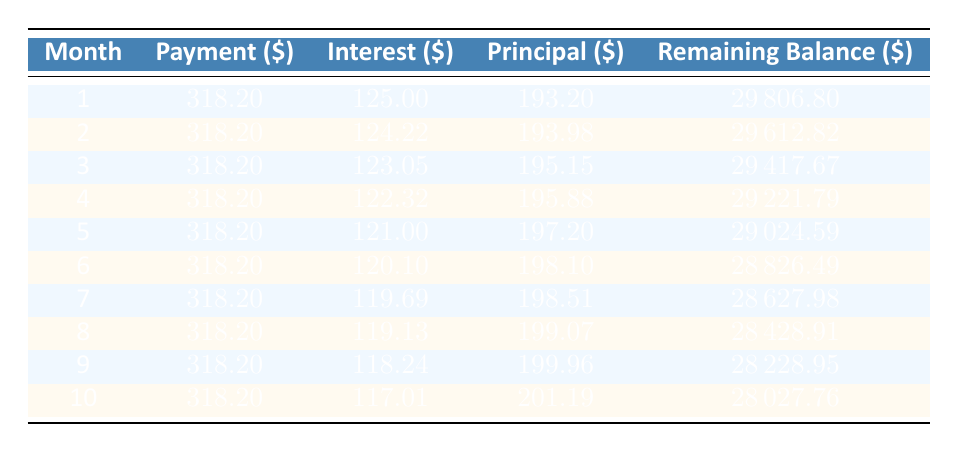What is the monthly payment amount? The table shows the monthly payment in the header, which is consistently listed as 318.20 for each month. Thus, it can be directly retrieved from the table.
Answer: 318.20 How much interest is paid in the first month? The first month's interest is specifically provided in the first row of the table where the month is labeled as 1. The interest amount is listed as 125.00.
Answer: 125.00 What is the remaining balance after the second payment? The remaining balance after the second payment is found in the second row of the table. It is listed as 29612.82.
Answer: 29612.82 Is the interest paid in the second month greater than the interest paid in the first month? Comparing the interest amounts in the first month (125.00) to the second month (124.22), the first month has a greater interest amount.
Answer: No What is the total interest paid in the first three months? To find the total interest paid in the first three months, we add the interest amounts for those months. This is 125.00 (Month 1) + 124.22 (Month 2) + 123.05 (Month 3) = 372.27.
Answer: 372.27 What is the difference in principal paid between the third and the first month? The principal for the first month is 193.20 and for the third month is 195.15. To find the difference, we subtract the first month's principal from the third month's principal: 195.15 - 193.20 = 1.95.
Answer: 1.95 How much total amount is paid in the first ten months? The total amount paid in the first ten months can be calculated by multiplying the monthly payment of 318.20 by 10, giving us 3182.00 (10 * 318.20 = 3182.00).
Answer: 3182.00 What is the average amount of principal paid in the first ten months? To find the average principal paid, we need the total principal for all ten months and divide by 10. Summing the principal amounts (193.20 + 193.98 + 195.15 + 195.88 + 197.20 + 198.10 + 198.51 + 199.07 + 199.96 + 201.19 = 1974.34), then dividing by 10 gives an average of 197.43.
Answer: 197.43 Does the principal payment increase every month? Reviewing the principal payments from month to month shows that the amount varies. Month 1 to Month 2 shows an increase, but Month 6 to Month 7 does not have a consistent increase. Thus, it's not increasing every month.
Answer: No 